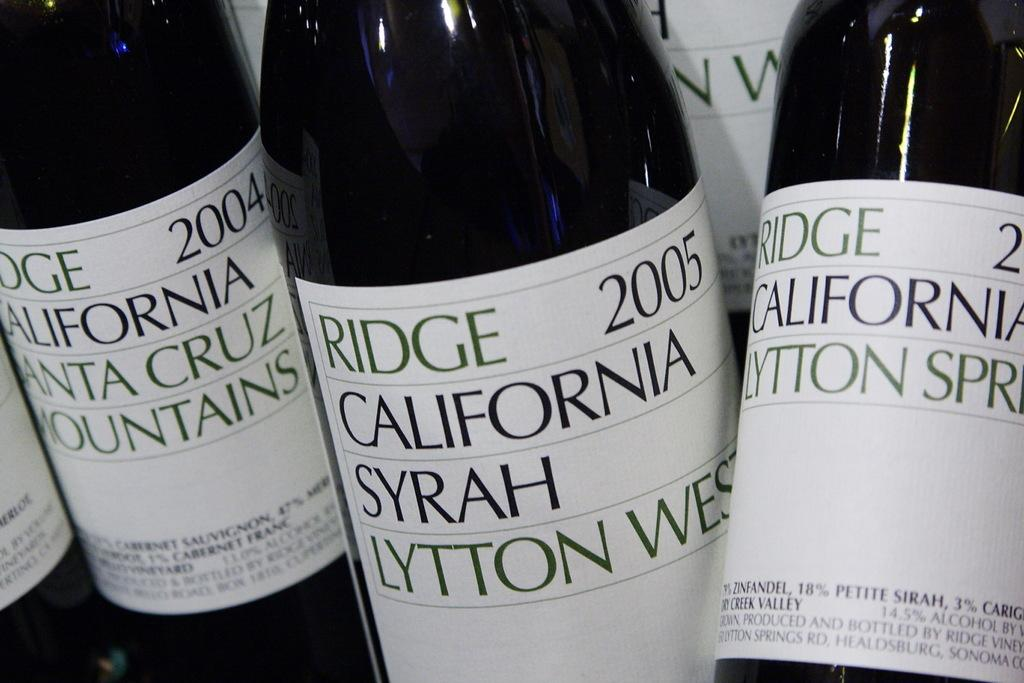<image>
Write a terse but informative summary of the picture. Bottles of Ridge wines with plain white labels. 